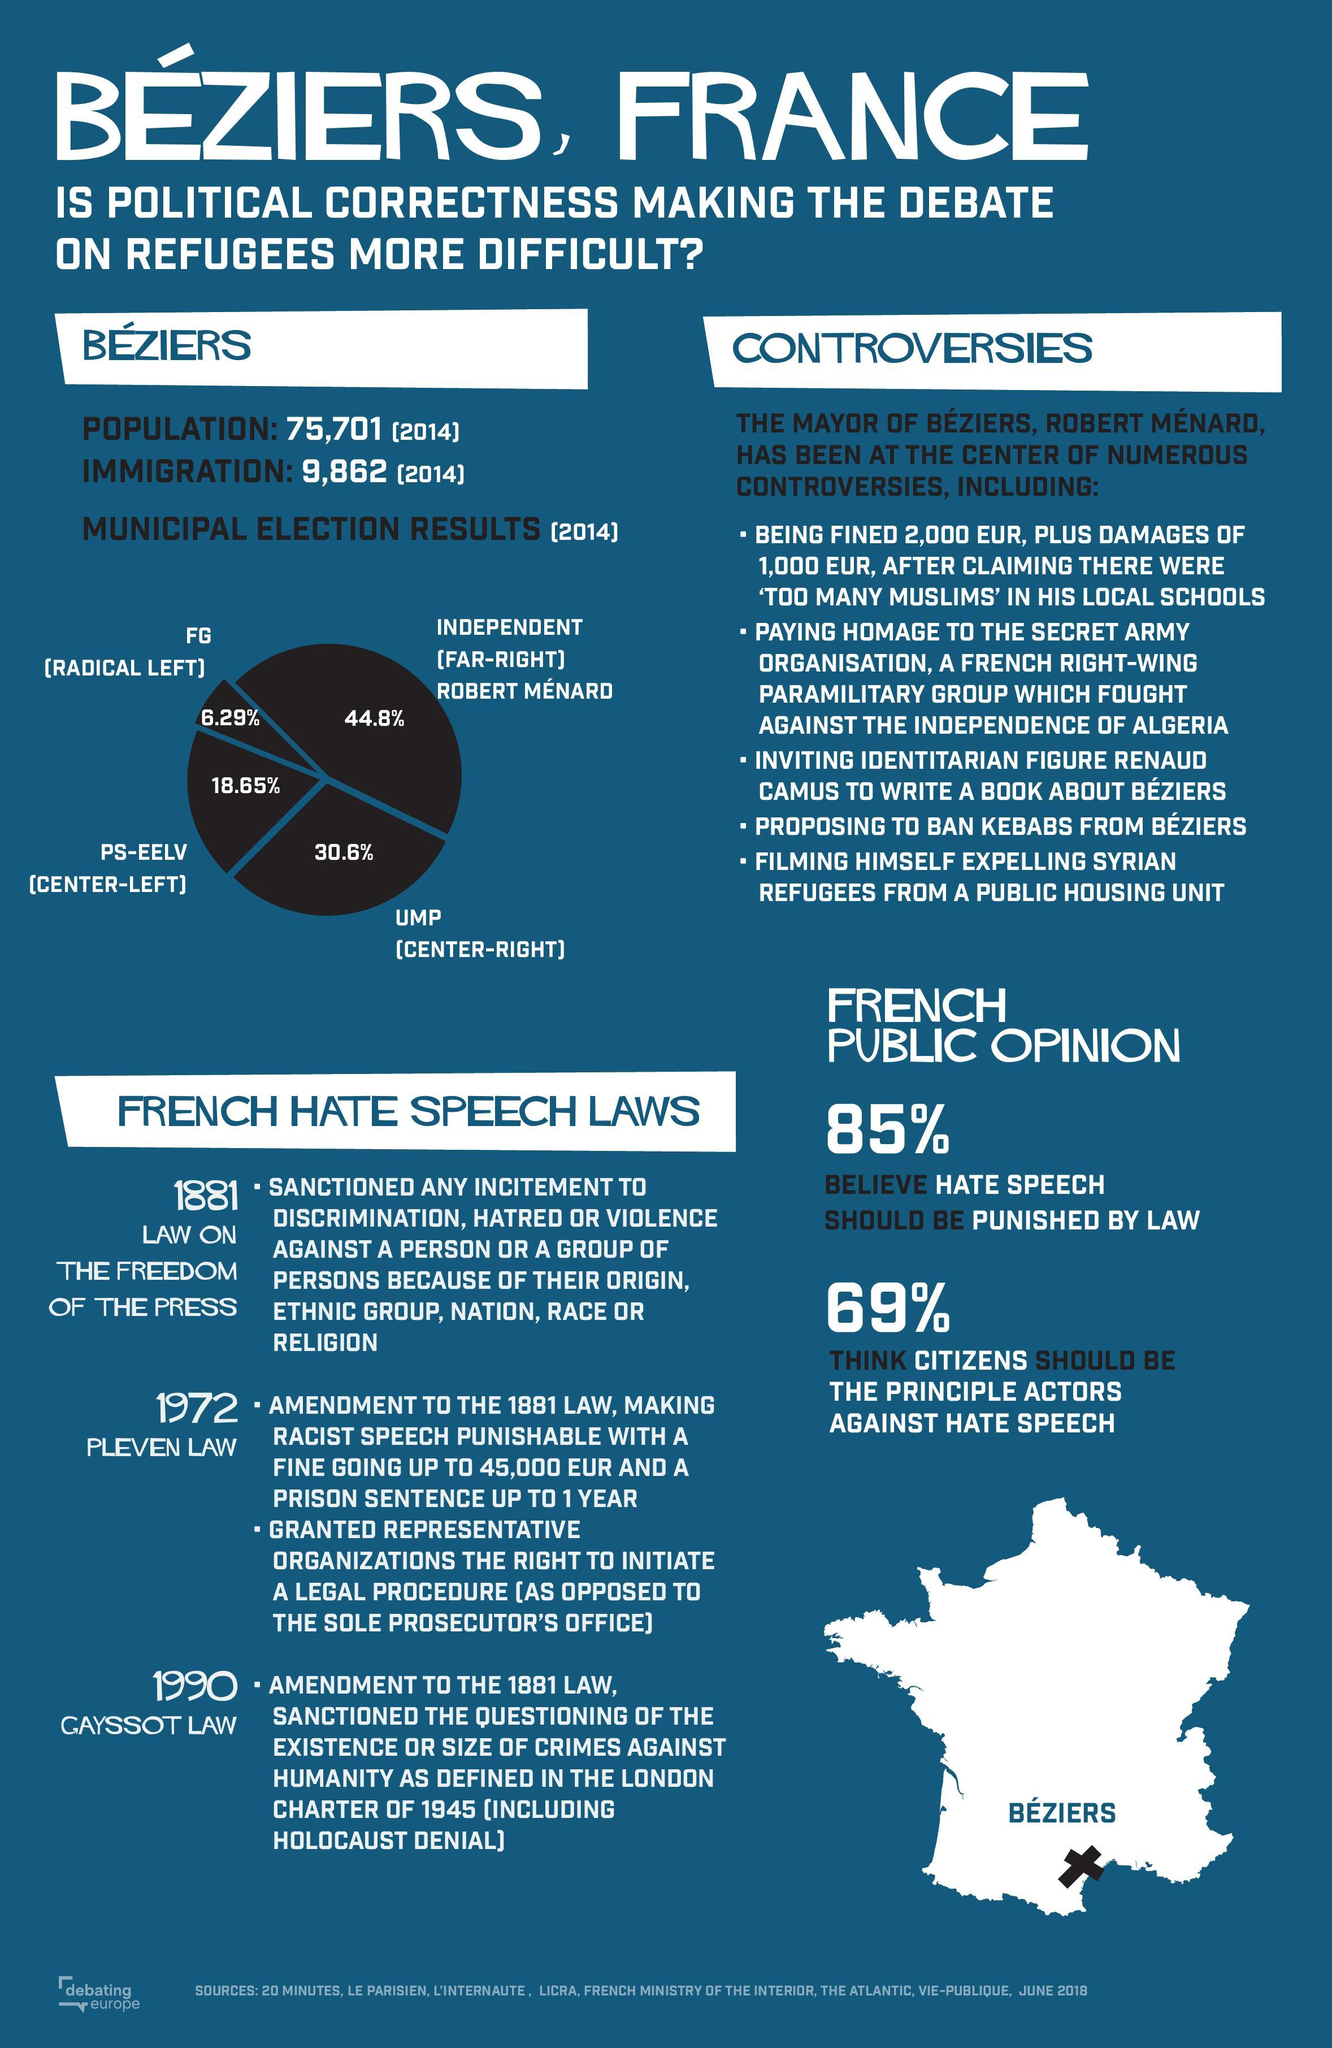What was the percentage of votes obtained by the the far-right?
Answer the question with a short phrase. 44.8% 